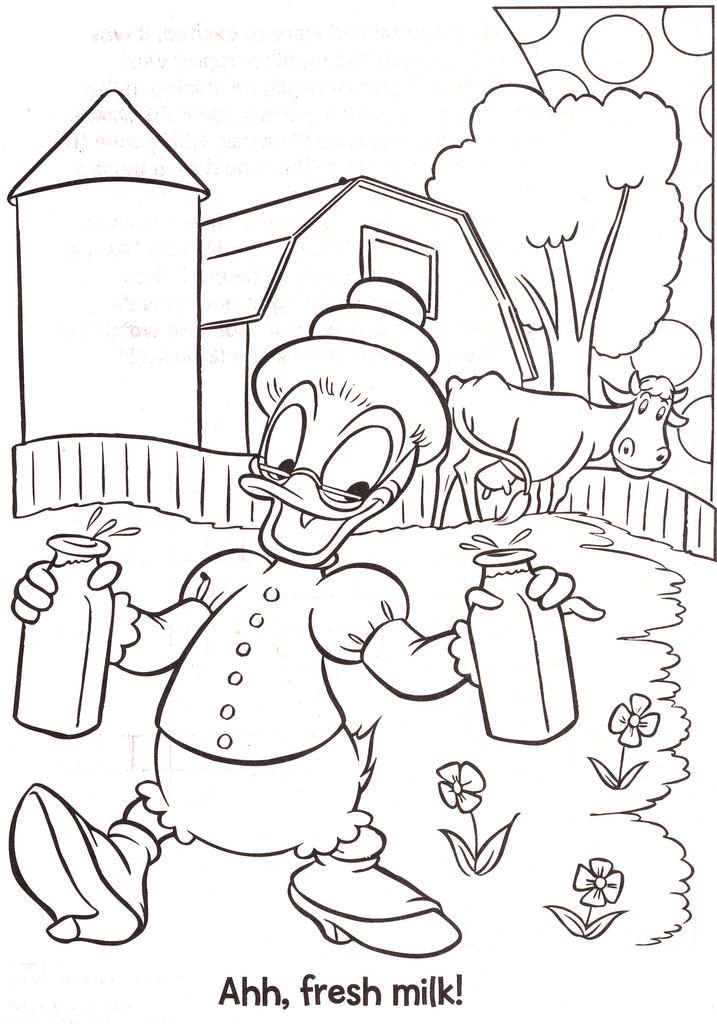What type of image is being described? The image is a drawing. What is located in the foreground of the drawing? There is a toy in the foreground of the drawing. What can be seen in the background of the drawing? There are trees and a cow in the background of the drawing. Is there any text present in the drawing? Yes, there is text written at the bottom of the drawing. How many bells are hanging from the trees in the drawing? There are no bells present in the drawing; it features a toy in the foreground, trees and a cow in the background, and text at the bottom. What color is the spot on the cow in the drawing? There is no mention of a spot on the cow in the drawing, so we cannot determine its color. 